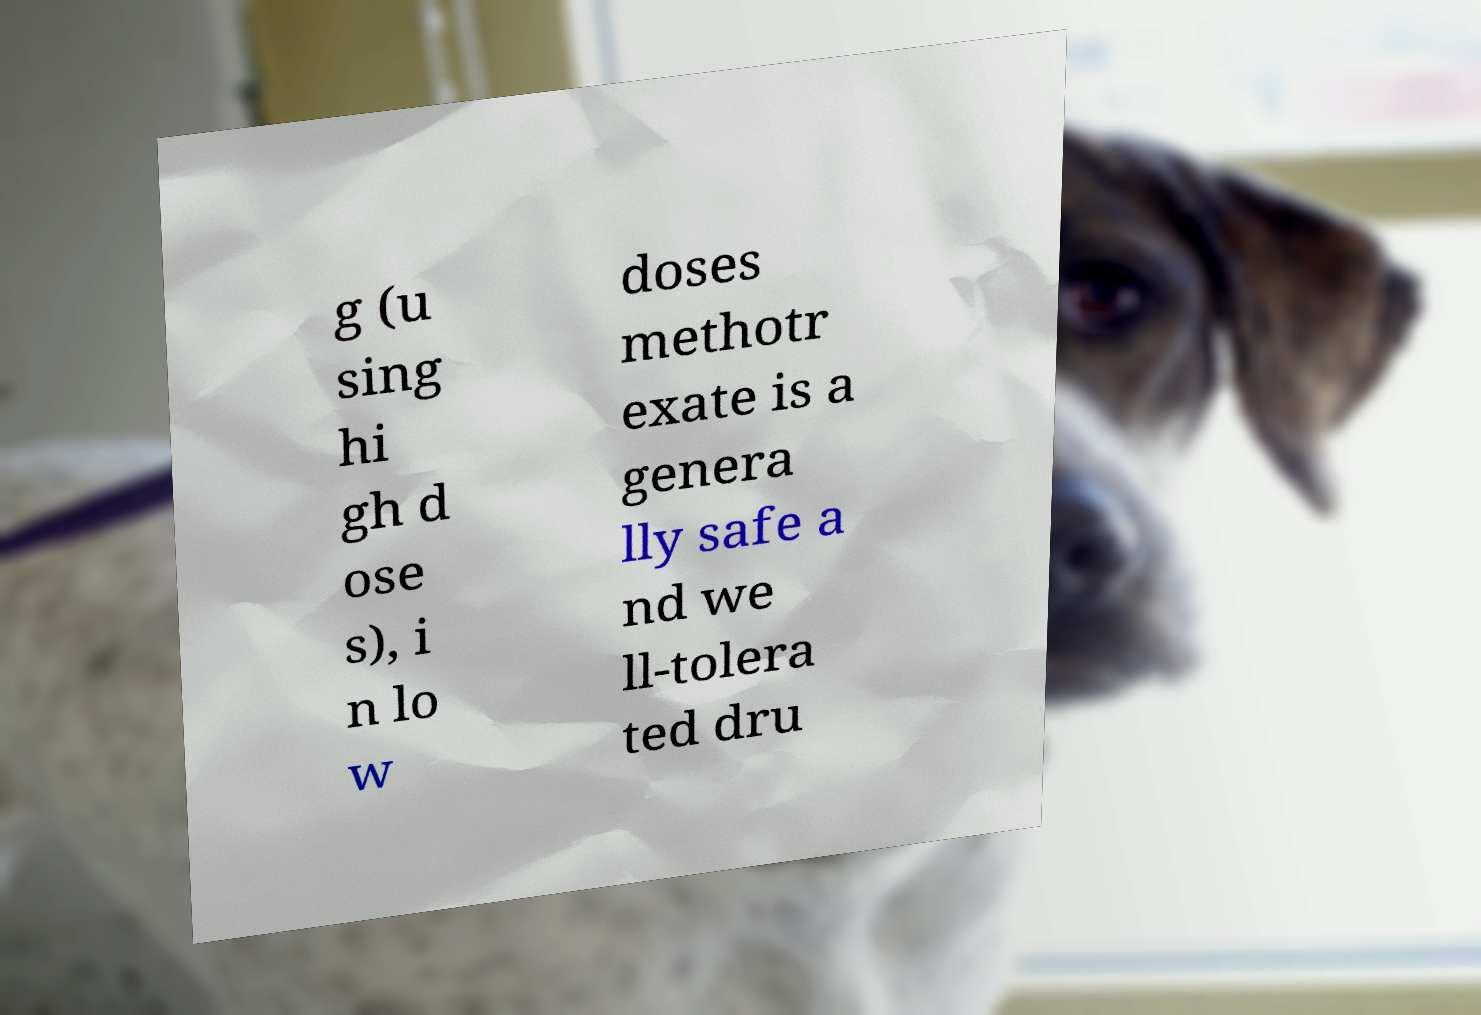Could you extract and type out the text from this image? g (u sing hi gh d ose s), i n lo w doses methotr exate is a genera lly safe a nd we ll-tolera ted dru 